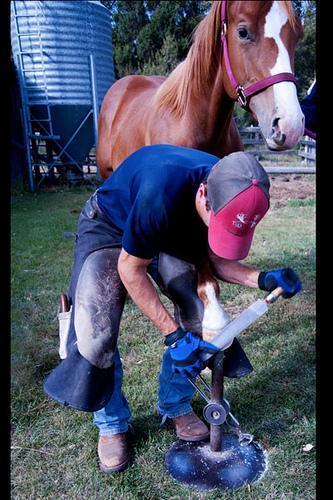How many horses are there?
Give a very brief answer. 1. 